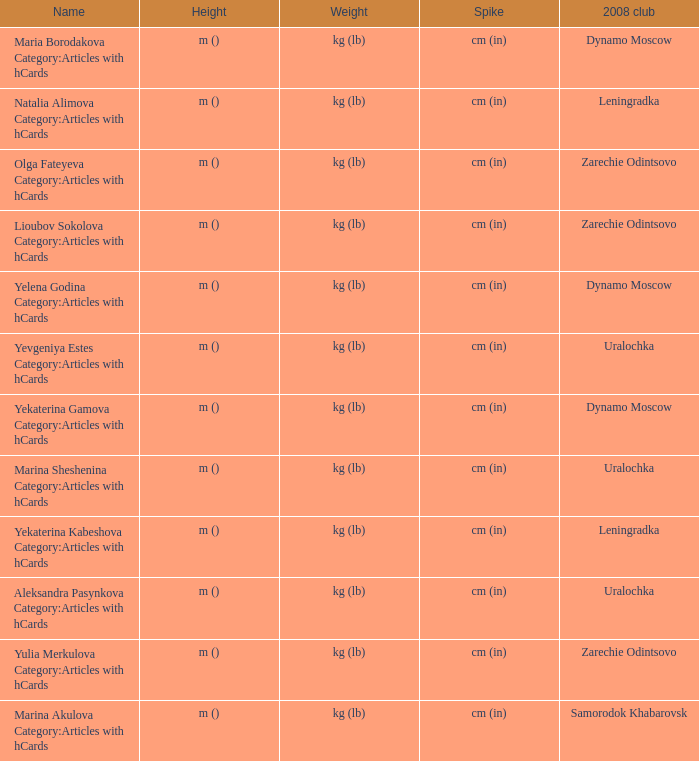In 2008, what is the club's name when it is known as uralochka? Yevgeniya Estes Category:Articles with hCards, Marina Sheshenina Category:Articles with hCards, Aleksandra Pasynkova Category:Articles with hCards. 